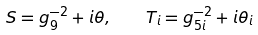<formula> <loc_0><loc_0><loc_500><loc_500>S = g _ { 9 } ^ { - 2 } + i \theta , \quad T _ { i } = g _ { 5 i } ^ { - 2 } + i \theta _ { i }</formula> 